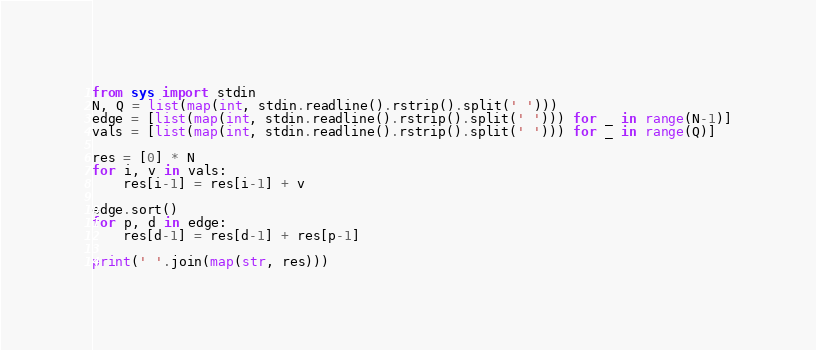<code> <loc_0><loc_0><loc_500><loc_500><_Python_>from sys import stdin
N, Q = list(map(int, stdin.readline().rstrip().split(' ')))
edge = [list(map(int, stdin.readline().rstrip().split(' '))) for _ in range(N-1)]
vals = [list(map(int, stdin.readline().rstrip().split(' '))) for _ in range(Q)]

res = [0] * N
for i, v in vals:
    res[i-1] = res[i-1] + v

edge.sort()
for p, d in edge:
    res[d-1] = res[d-1] + res[p-1]

print(' '.join(map(str, res)))</code> 